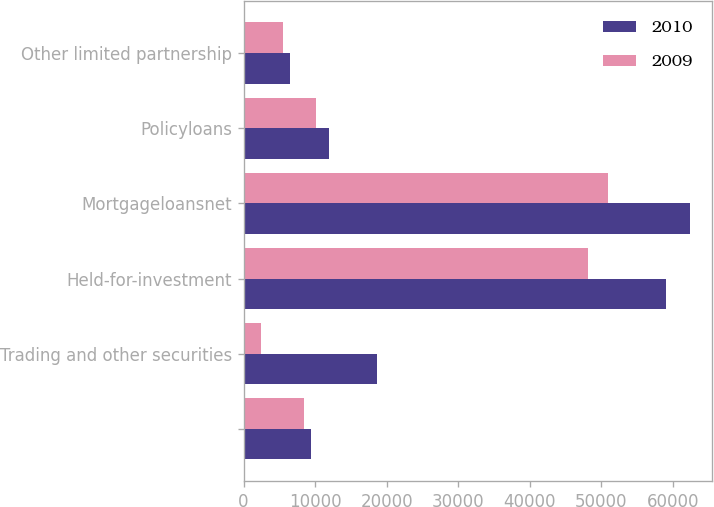Convert chart. <chart><loc_0><loc_0><loc_500><loc_500><stacked_bar_chart><ecel><fcel>Unnamed: 1<fcel>Trading and other securities<fcel>Held-for-investment<fcel>Mortgageloansnet<fcel>Policyloans<fcel>Other limited partnership<nl><fcel>2010<fcel>9387<fcel>18589<fcel>59055<fcel>62376<fcel>11914<fcel>6416<nl><fcel>2009<fcel>8374<fcel>2384<fcel>48181<fcel>50909<fcel>10061<fcel>5508<nl></chart> 